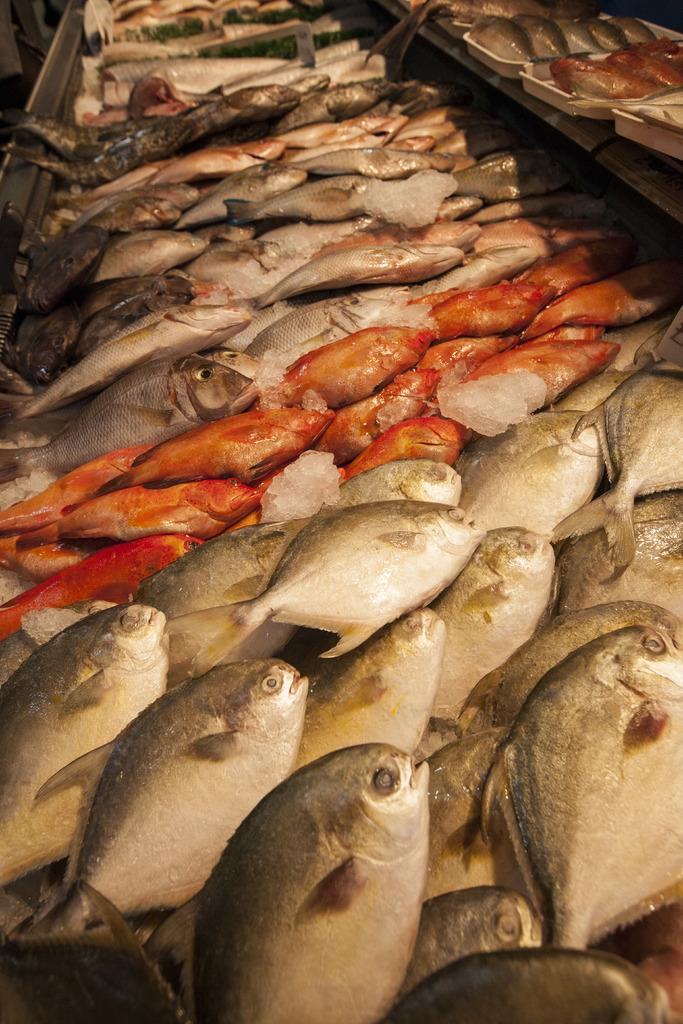What type of animals can be seen in the image? There are fishes in the image. What is present in the image besides the fishes? There are rock salt pieces in the image. Where are the fishes located in the image? The fishes are in trays on the right side top corner of the image. What can be seen in the left side top corner of the image? There is an object in the left side top corner of the image. What type of orange plantation can be seen in the image? There is no orange plantation present in the image. What kind of agreement is being made between the fishes in the image? The fishes in the image are not making any agreements; they are simply present in the trays. 